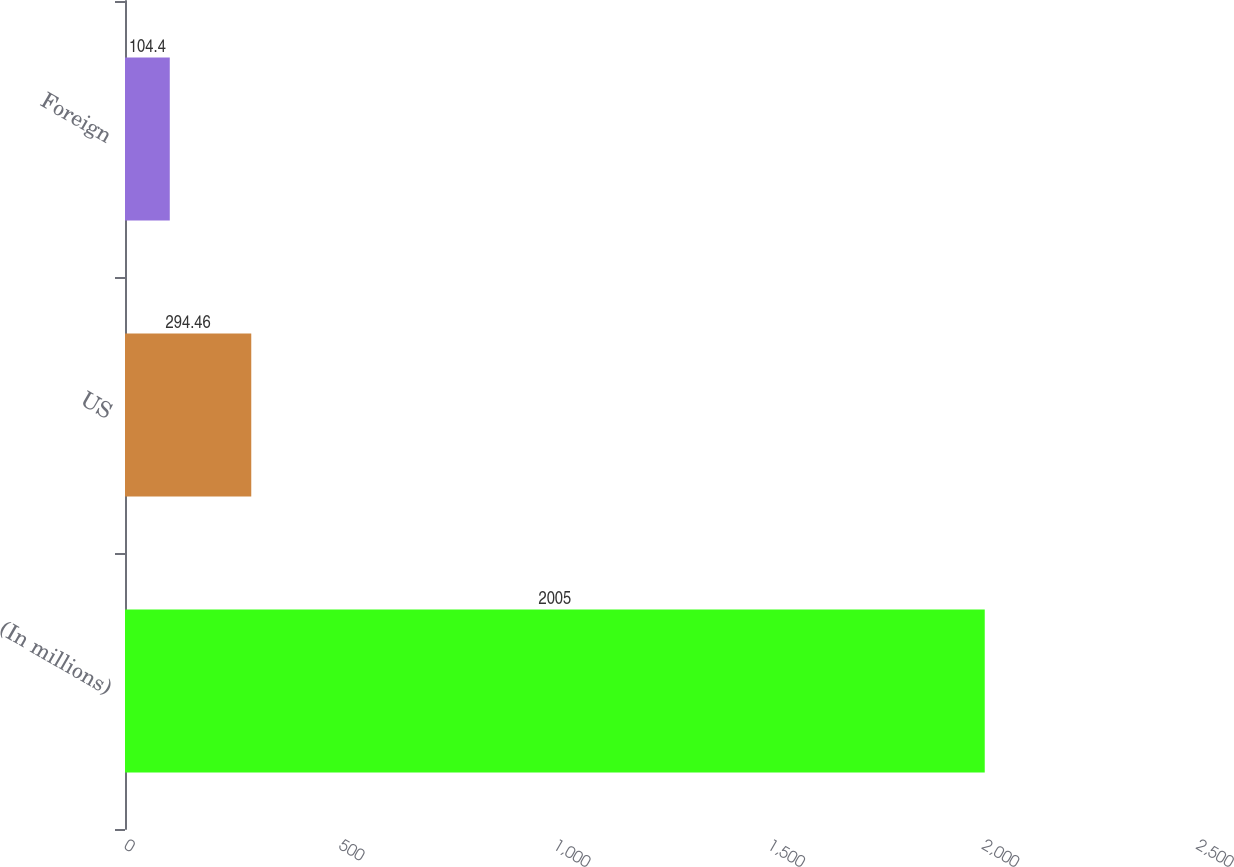<chart> <loc_0><loc_0><loc_500><loc_500><bar_chart><fcel>(In millions)<fcel>US<fcel>Foreign<nl><fcel>2005<fcel>294.46<fcel>104.4<nl></chart> 